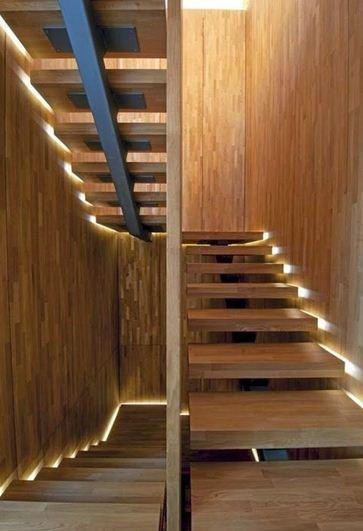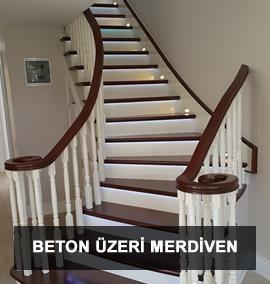The first image is the image on the left, the second image is the image on the right. Assess this claim about the two images: "The stairs in the image on the right curve near a large open window.". Correct or not? Answer yes or no. No. 